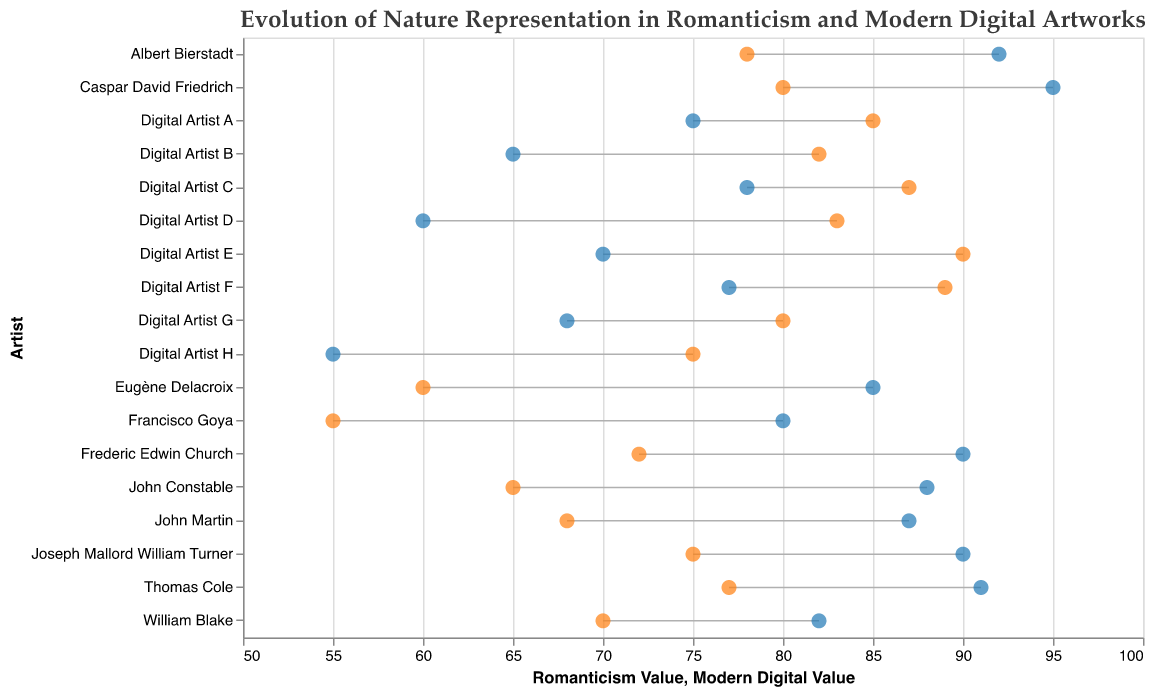What does the title of the plot convey? The title of the plot is "Evolution of Nature Representation in Romanticism and Modern Digital Artworks". It suggests that the plot compares how themes related to nature in Romanticism artworks have evolved when represented in modern digital artworks.
Answer: Evolution of Nature Representation in Romanticism and Modern Digital Artworks What do the two different colors of points represent? The plot uses two different colors of points: blue and orange. The blue points represent Romanticism values, while the orange points represent Modern Digital values.
Answer: Blue for Romanticism values and orange for Modern Digital values How many artists are represented in the plot? The y-axis lists the names of the artists, and there are a total of 18 artists.
Answer: 18 Which artist has the highest Romanticism value? By looking at the x-position of the blue points, Caspar David Friedrich with a value of 95 has the highest Romanticism value.
Answer: Caspar David Friedrich What is the difference between Romanticism value and Modern Digital value for Digital Artist C? The Romanticism value for Digital Artist C is 78, and the Modern Digital value is 87. The difference is 87 - 78 = 9.
Answer: 9 Which artist/thematic pair shows the greatest decrease from Romanticism to Modern Digital value? By examining the line lengths, Francisco Goya with the theme of Dark Romanticism shows the greatest decrease, going from 80 to 55, a reduction of 25 points.
Answer: Francisco Goya with Dark Romanticism On average, how do Modern Digital values compare to Romanticism values for the theme "Apocalyptic Visions"? The artists for Apocalyptic Visions are John Martin and Digital Artist G. The Romanticism values are 87 and 68. The Modern Digital values are 68 and 80. (87+68)/2 = 77.5 for Romanticism and (68+80)/2 = 74 for Modern Digital.
Answer: Romanticism values are higher on average Which digital artist emphasizes "Mythological Nature" the most? The plot indicates that Digital Artist E has the highest Modern Digital value for Mythological Nature with a value of 90.
Answer: Digital Artist E For "American Landscape," which value set (Romanticism or Modern Digital) has the higher average? The artists for American Landscape are Albert Bierstadt, Frederic Edwin Church, and Digital Artist C. Romanticism values: 92, 90, 78. Modern Digital values: 78, 72, 87. Averages are (92+90+78)/3 = 86.67 for Romanticism and (78+72+87)/3 = 79 for Modern Digital.
Answer: Romanticism values have a higher average What is the range of values for Modern Digital Art in "Dramatic Scenery"? For Dramatic Scenery, the Modern Digital values are 60 for Eugène Delacroix and 83 for Digital Artist D. The range is 83 - 60 = 23.
Answer: 23 